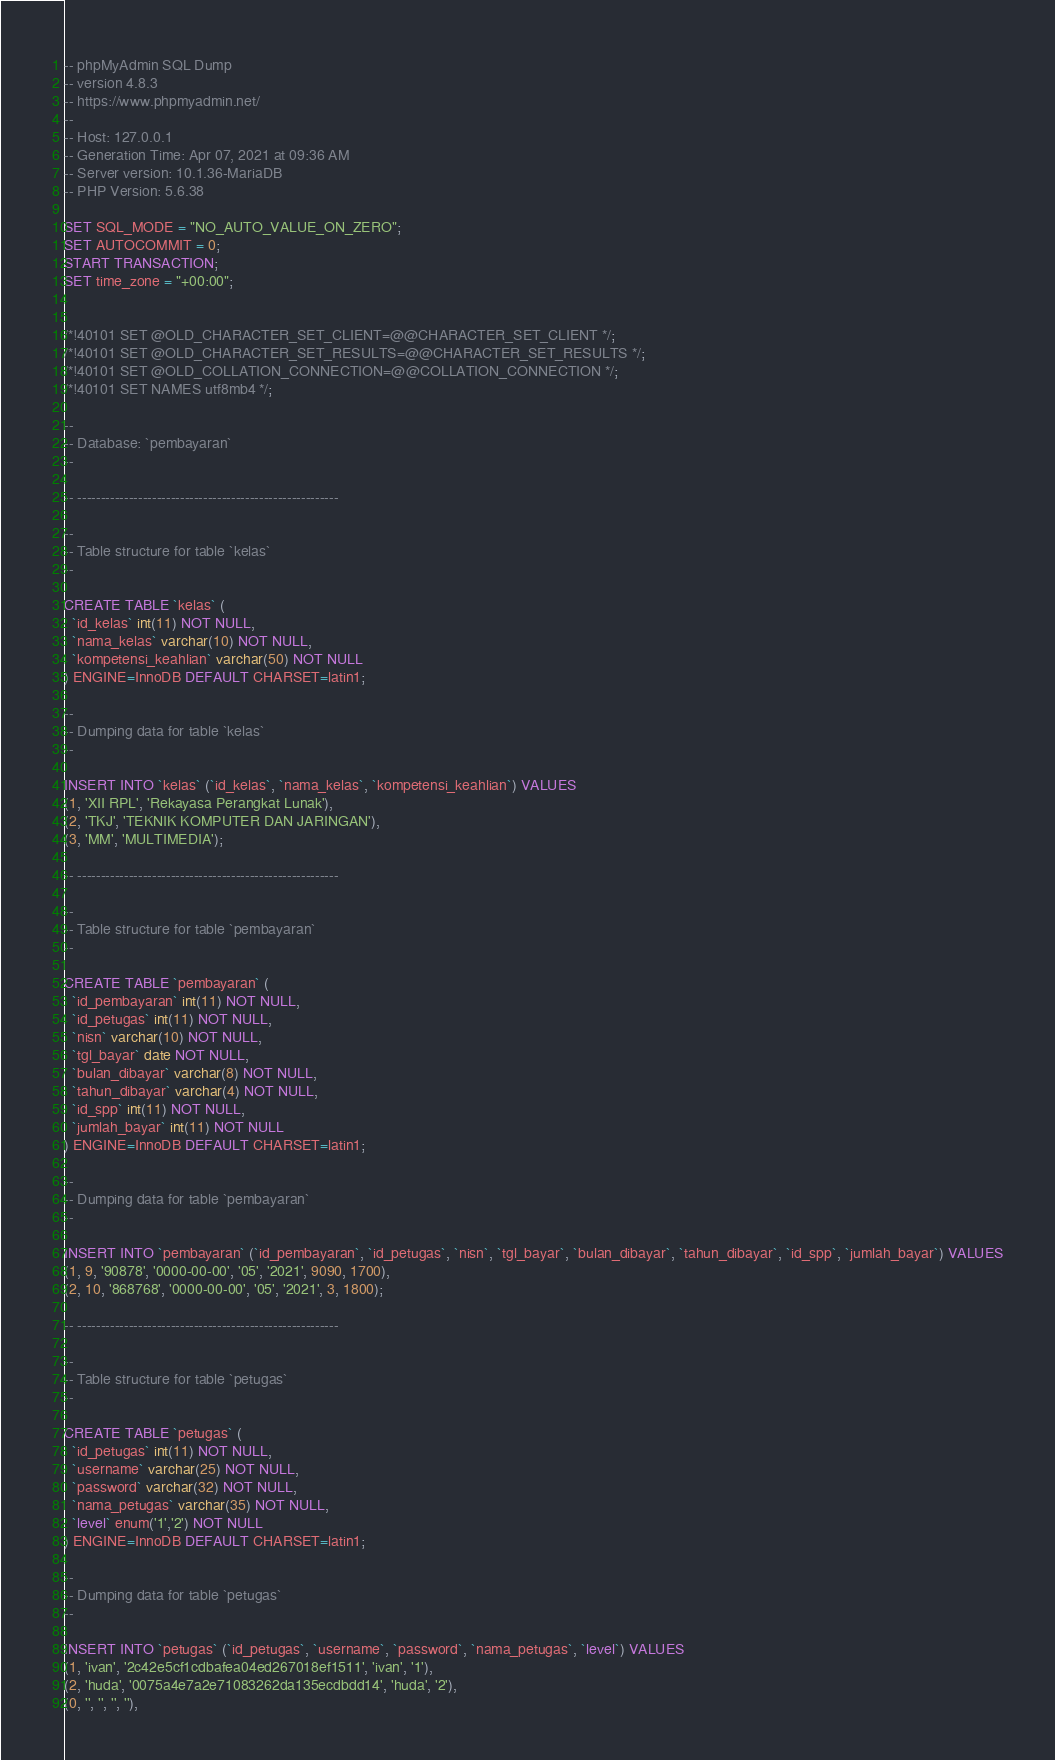Convert code to text. <code><loc_0><loc_0><loc_500><loc_500><_SQL_>-- phpMyAdmin SQL Dump
-- version 4.8.3
-- https://www.phpmyadmin.net/
--
-- Host: 127.0.0.1
-- Generation Time: Apr 07, 2021 at 09:36 AM
-- Server version: 10.1.36-MariaDB
-- PHP Version: 5.6.38

SET SQL_MODE = "NO_AUTO_VALUE_ON_ZERO";
SET AUTOCOMMIT = 0;
START TRANSACTION;
SET time_zone = "+00:00";


/*!40101 SET @OLD_CHARACTER_SET_CLIENT=@@CHARACTER_SET_CLIENT */;
/*!40101 SET @OLD_CHARACTER_SET_RESULTS=@@CHARACTER_SET_RESULTS */;
/*!40101 SET @OLD_COLLATION_CONNECTION=@@COLLATION_CONNECTION */;
/*!40101 SET NAMES utf8mb4 */;

--
-- Database: `pembayaran`
--

-- --------------------------------------------------------

--
-- Table structure for table `kelas`
--

CREATE TABLE `kelas` (
  `id_kelas` int(11) NOT NULL,
  `nama_kelas` varchar(10) NOT NULL,
  `kompetensi_keahlian` varchar(50) NOT NULL
) ENGINE=InnoDB DEFAULT CHARSET=latin1;

--
-- Dumping data for table `kelas`
--

INSERT INTO `kelas` (`id_kelas`, `nama_kelas`, `kompetensi_keahlian`) VALUES
(1, 'XII RPL', 'Rekayasa Perangkat Lunak'),
(2, 'TKJ', 'TEKNIK KOMPUTER DAN JARINGAN'),
(3, 'MM', 'MULTIMEDIA');

-- --------------------------------------------------------

--
-- Table structure for table `pembayaran`
--

CREATE TABLE `pembayaran` (
  `id_pembayaran` int(11) NOT NULL,
  `id_petugas` int(11) NOT NULL,
  `nisn` varchar(10) NOT NULL,
  `tgl_bayar` date NOT NULL,
  `bulan_dibayar` varchar(8) NOT NULL,
  `tahun_dibayar` varchar(4) NOT NULL,
  `id_spp` int(11) NOT NULL,
  `jumlah_bayar` int(11) NOT NULL
) ENGINE=InnoDB DEFAULT CHARSET=latin1;

--
-- Dumping data for table `pembayaran`
--

INSERT INTO `pembayaran` (`id_pembayaran`, `id_petugas`, `nisn`, `tgl_bayar`, `bulan_dibayar`, `tahun_dibayar`, `id_spp`, `jumlah_bayar`) VALUES
(1, 9, '90878', '0000-00-00', '05', '2021', 9090, 1700),
(2, 10, '868768', '0000-00-00', '05', '2021', 3, 1800);

-- --------------------------------------------------------

--
-- Table structure for table `petugas`
--

CREATE TABLE `petugas` (
  `id_petugas` int(11) NOT NULL,
  `username` varchar(25) NOT NULL,
  `password` varchar(32) NOT NULL,
  `nama_petugas` varchar(35) NOT NULL,
  `level` enum('1','2') NOT NULL
) ENGINE=InnoDB DEFAULT CHARSET=latin1;

--
-- Dumping data for table `petugas`
--

INSERT INTO `petugas` (`id_petugas`, `username`, `password`, `nama_petugas`, `level`) VALUES
(1, 'ivan', '2c42e5cf1cdbafea04ed267018ef1511', 'ivan', '1'),
(2, 'huda', '0075a4e7a2e71083262da135ecdbdd14', 'huda', '2'),
(0, '', '', '', ''),</code> 